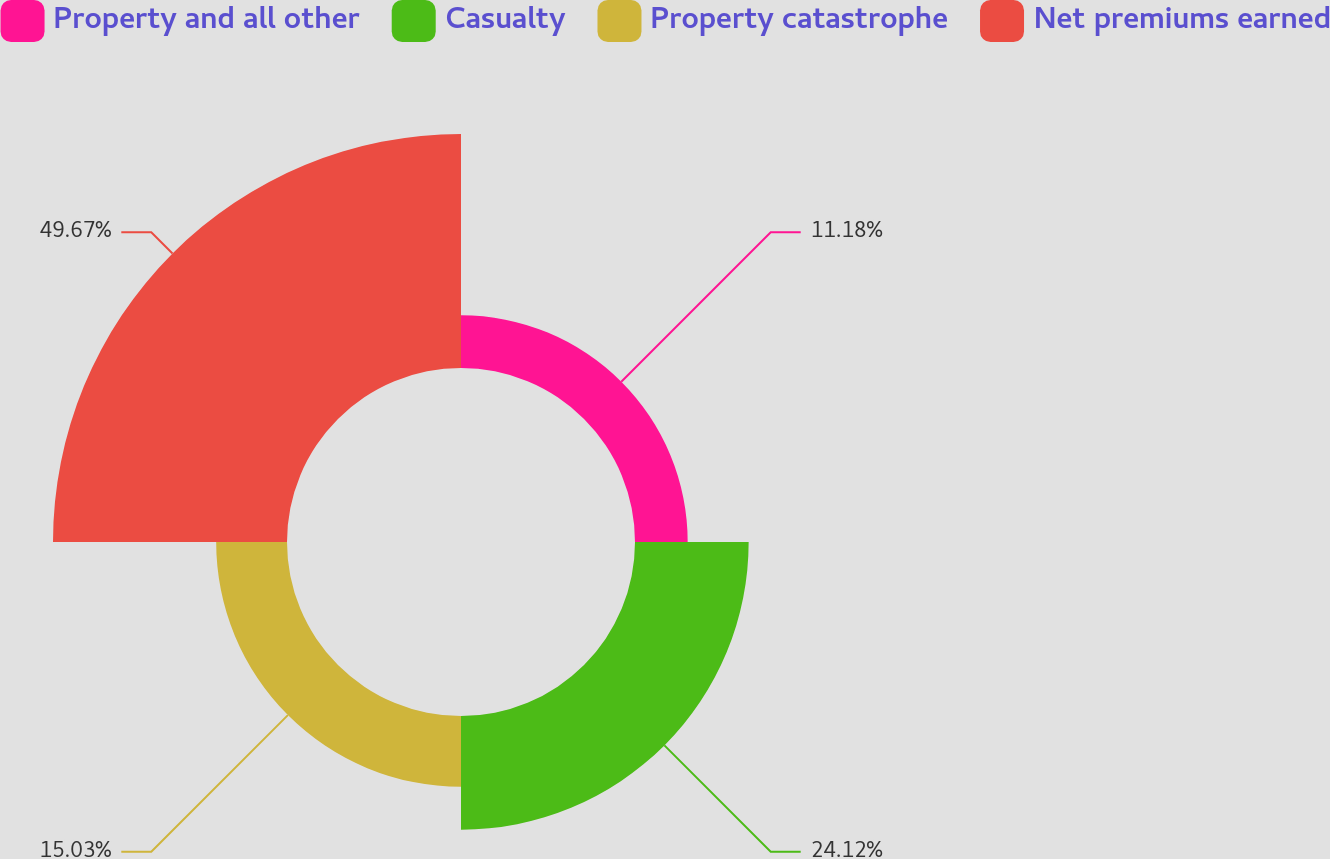Convert chart to OTSL. <chart><loc_0><loc_0><loc_500><loc_500><pie_chart><fcel>Property and all other<fcel>Casualty<fcel>Property catastrophe<fcel>Net premiums earned<nl><fcel>11.18%<fcel>24.12%<fcel>15.03%<fcel>49.66%<nl></chart> 